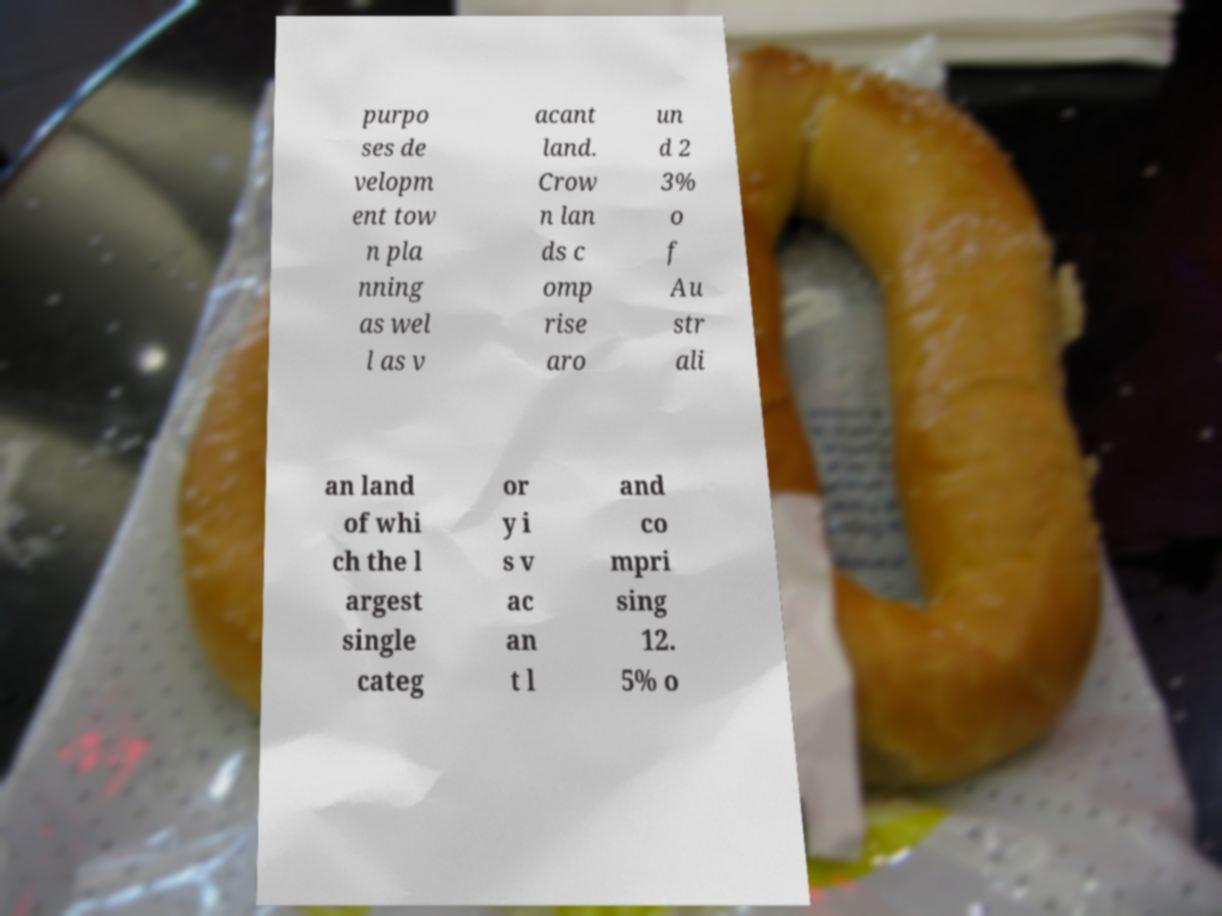Can you accurately transcribe the text from the provided image for me? purpo ses de velopm ent tow n pla nning as wel l as v acant land. Crow n lan ds c omp rise aro un d 2 3% o f Au str ali an land of whi ch the l argest single categ or y i s v ac an t l and co mpri sing 12. 5% o 